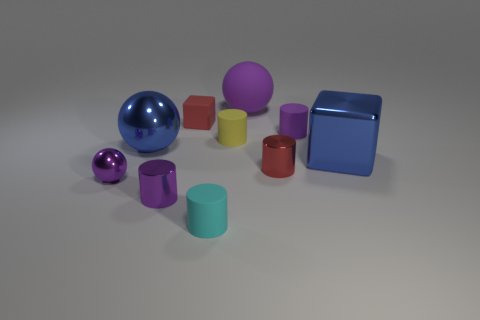How many other objects are the same size as the purple metal cylinder?
Ensure brevity in your answer.  6. Do the tiny purple object behind the tiny yellow matte thing and the cyan thing have the same shape?
Make the answer very short. Yes. Is the number of small purple cylinders right of the red matte thing greater than the number of blue matte cubes?
Give a very brief answer. Yes. What material is the cylinder that is in front of the tiny yellow rubber cylinder and right of the big matte sphere?
Make the answer very short. Metal. How many purple things are on the right side of the blue ball and in front of the large blue sphere?
Your answer should be compact. 1. What is the material of the big block?
Offer a very short reply. Metal. Are there an equal number of purple balls in front of the small purple sphere and tiny gray objects?
Provide a short and direct response. Yes. How many blue shiny things have the same shape as the small yellow thing?
Give a very brief answer. 0. Do the tiny yellow rubber object and the tiny purple matte object have the same shape?
Provide a short and direct response. Yes. What number of things are large blue objects behind the metal block or small rubber things?
Your response must be concise. 5. 